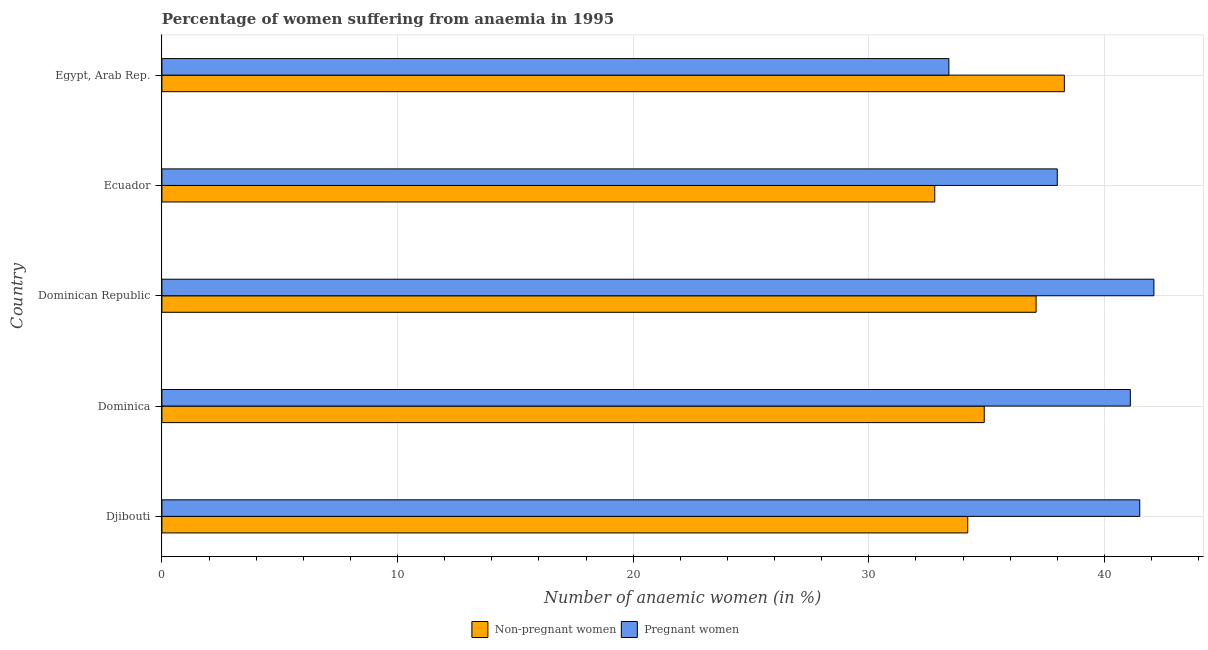How many groups of bars are there?
Provide a short and direct response. 5. Are the number of bars per tick equal to the number of legend labels?
Offer a terse response. Yes. Are the number of bars on each tick of the Y-axis equal?
Offer a terse response. Yes. How many bars are there on the 5th tick from the top?
Your response must be concise. 2. How many bars are there on the 5th tick from the bottom?
Provide a short and direct response. 2. What is the label of the 4th group of bars from the top?
Offer a very short reply. Dominica. In how many cases, is the number of bars for a given country not equal to the number of legend labels?
Your answer should be very brief. 0. What is the percentage of non-pregnant anaemic women in Djibouti?
Provide a succinct answer. 34.2. Across all countries, what is the maximum percentage of pregnant anaemic women?
Your answer should be compact. 42.1. Across all countries, what is the minimum percentage of pregnant anaemic women?
Your response must be concise. 33.4. In which country was the percentage of non-pregnant anaemic women maximum?
Provide a short and direct response. Egypt, Arab Rep. In which country was the percentage of non-pregnant anaemic women minimum?
Offer a very short reply. Ecuador. What is the total percentage of pregnant anaemic women in the graph?
Your answer should be compact. 196.1. What is the difference between the percentage of pregnant anaemic women in Egypt, Arab Rep. and the percentage of non-pregnant anaemic women in Dominica?
Offer a terse response. -1.5. What is the average percentage of pregnant anaemic women per country?
Provide a short and direct response. 39.22. In how many countries, is the percentage of non-pregnant anaemic women greater than 16 %?
Ensure brevity in your answer.  5. What is the ratio of the percentage of non-pregnant anaemic women in Djibouti to that in Dominican Republic?
Keep it short and to the point. 0.92. Is the percentage of pregnant anaemic women in Djibouti less than that in Dominica?
Ensure brevity in your answer.  No. Is the difference between the percentage of pregnant anaemic women in Dominican Republic and Ecuador greater than the difference between the percentage of non-pregnant anaemic women in Dominican Republic and Ecuador?
Give a very brief answer. No. What is the difference between the highest and the lowest percentage of non-pregnant anaemic women?
Your answer should be compact. 5.5. In how many countries, is the percentage of non-pregnant anaemic women greater than the average percentage of non-pregnant anaemic women taken over all countries?
Your response must be concise. 2. Is the sum of the percentage of non-pregnant anaemic women in Dominica and Dominican Republic greater than the maximum percentage of pregnant anaemic women across all countries?
Your answer should be compact. Yes. What does the 1st bar from the top in Egypt, Arab Rep. represents?
Provide a succinct answer. Pregnant women. What does the 1st bar from the bottom in Djibouti represents?
Your answer should be very brief. Non-pregnant women. What is the difference between two consecutive major ticks on the X-axis?
Your answer should be compact. 10. Are the values on the major ticks of X-axis written in scientific E-notation?
Offer a terse response. No. Does the graph contain any zero values?
Make the answer very short. No. Does the graph contain grids?
Your response must be concise. Yes. Where does the legend appear in the graph?
Make the answer very short. Bottom center. How many legend labels are there?
Provide a succinct answer. 2. What is the title of the graph?
Provide a short and direct response. Percentage of women suffering from anaemia in 1995. Does "Pregnant women" appear as one of the legend labels in the graph?
Provide a succinct answer. Yes. What is the label or title of the X-axis?
Provide a short and direct response. Number of anaemic women (in %). What is the label or title of the Y-axis?
Your response must be concise. Country. What is the Number of anaemic women (in %) of Non-pregnant women in Djibouti?
Your answer should be very brief. 34.2. What is the Number of anaemic women (in %) in Pregnant women in Djibouti?
Offer a very short reply. 41.5. What is the Number of anaemic women (in %) in Non-pregnant women in Dominica?
Give a very brief answer. 34.9. What is the Number of anaemic women (in %) in Pregnant women in Dominica?
Ensure brevity in your answer.  41.1. What is the Number of anaemic women (in %) in Non-pregnant women in Dominican Republic?
Provide a short and direct response. 37.1. What is the Number of anaemic women (in %) in Pregnant women in Dominican Republic?
Offer a terse response. 42.1. What is the Number of anaemic women (in %) in Non-pregnant women in Ecuador?
Make the answer very short. 32.8. What is the Number of anaemic women (in %) in Pregnant women in Ecuador?
Your answer should be compact. 38. What is the Number of anaemic women (in %) in Non-pregnant women in Egypt, Arab Rep.?
Give a very brief answer. 38.3. What is the Number of anaemic women (in %) of Pregnant women in Egypt, Arab Rep.?
Give a very brief answer. 33.4. Across all countries, what is the maximum Number of anaemic women (in %) in Non-pregnant women?
Make the answer very short. 38.3. Across all countries, what is the maximum Number of anaemic women (in %) of Pregnant women?
Ensure brevity in your answer.  42.1. Across all countries, what is the minimum Number of anaemic women (in %) in Non-pregnant women?
Your response must be concise. 32.8. Across all countries, what is the minimum Number of anaemic women (in %) in Pregnant women?
Offer a very short reply. 33.4. What is the total Number of anaemic women (in %) of Non-pregnant women in the graph?
Your response must be concise. 177.3. What is the total Number of anaemic women (in %) of Pregnant women in the graph?
Provide a succinct answer. 196.1. What is the difference between the Number of anaemic women (in %) of Pregnant women in Djibouti and that in Dominica?
Ensure brevity in your answer.  0.4. What is the difference between the Number of anaemic women (in %) of Non-pregnant women in Djibouti and that in Dominican Republic?
Your answer should be compact. -2.9. What is the difference between the Number of anaemic women (in %) in Non-pregnant women in Djibouti and that in Ecuador?
Make the answer very short. 1.4. What is the difference between the Number of anaemic women (in %) in Pregnant women in Djibouti and that in Ecuador?
Your answer should be very brief. 3.5. What is the difference between the Number of anaemic women (in %) of Pregnant women in Djibouti and that in Egypt, Arab Rep.?
Offer a very short reply. 8.1. What is the difference between the Number of anaemic women (in %) in Non-pregnant women in Dominica and that in Ecuador?
Provide a succinct answer. 2.1. What is the difference between the Number of anaemic women (in %) of Pregnant women in Dominica and that in Ecuador?
Provide a succinct answer. 3.1. What is the difference between the Number of anaemic women (in %) of Non-pregnant women in Dominican Republic and that in Ecuador?
Your answer should be very brief. 4.3. What is the difference between the Number of anaemic women (in %) in Pregnant women in Dominican Republic and that in Ecuador?
Provide a succinct answer. 4.1. What is the difference between the Number of anaemic women (in %) of Pregnant women in Ecuador and that in Egypt, Arab Rep.?
Your answer should be compact. 4.6. What is the difference between the Number of anaemic women (in %) of Non-pregnant women in Djibouti and the Number of anaemic women (in %) of Pregnant women in Ecuador?
Your answer should be very brief. -3.8. What is the difference between the Number of anaemic women (in %) of Non-pregnant women in Djibouti and the Number of anaemic women (in %) of Pregnant women in Egypt, Arab Rep.?
Your response must be concise. 0.8. What is the difference between the Number of anaemic women (in %) in Non-pregnant women in Dominica and the Number of anaemic women (in %) in Pregnant women in Dominican Republic?
Offer a terse response. -7.2. What is the difference between the Number of anaemic women (in %) in Non-pregnant women in Dominican Republic and the Number of anaemic women (in %) in Pregnant women in Egypt, Arab Rep.?
Offer a terse response. 3.7. What is the average Number of anaemic women (in %) in Non-pregnant women per country?
Offer a very short reply. 35.46. What is the average Number of anaemic women (in %) in Pregnant women per country?
Your response must be concise. 39.22. What is the difference between the Number of anaemic women (in %) in Non-pregnant women and Number of anaemic women (in %) in Pregnant women in Djibouti?
Make the answer very short. -7.3. What is the ratio of the Number of anaemic women (in %) in Non-pregnant women in Djibouti to that in Dominica?
Provide a succinct answer. 0.98. What is the ratio of the Number of anaemic women (in %) in Pregnant women in Djibouti to that in Dominica?
Keep it short and to the point. 1.01. What is the ratio of the Number of anaemic women (in %) of Non-pregnant women in Djibouti to that in Dominican Republic?
Keep it short and to the point. 0.92. What is the ratio of the Number of anaemic women (in %) of Pregnant women in Djibouti to that in Dominican Republic?
Keep it short and to the point. 0.99. What is the ratio of the Number of anaemic women (in %) in Non-pregnant women in Djibouti to that in Ecuador?
Offer a very short reply. 1.04. What is the ratio of the Number of anaemic women (in %) in Pregnant women in Djibouti to that in Ecuador?
Make the answer very short. 1.09. What is the ratio of the Number of anaemic women (in %) in Non-pregnant women in Djibouti to that in Egypt, Arab Rep.?
Make the answer very short. 0.89. What is the ratio of the Number of anaemic women (in %) of Pregnant women in Djibouti to that in Egypt, Arab Rep.?
Your answer should be very brief. 1.24. What is the ratio of the Number of anaemic women (in %) of Non-pregnant women in Dominica to that in Dominican Republic?
Offer a very short reply. 0.94. What is the ratio of the Number of anaemic women (in %) in Pregnant women in Dominica to that in Dominican Republic?
Your answer should be compact. 0.98. What is the ratio of the Number of anaemic women (in %) of Non-pregnant women in Dominica to that in Ecuador?
Offer a very short reply. 1.06. What is the ratio of the Number of anaemic women (in %) in Pregnant women in Dominica to that in Ecuador?
Offer a very short reply. 1.08. What is the ratio of the Number of anaemic women (in %) of Non-pregnant women in Dominica to that in Egypt, Arab Rep.?
Give a very brief answer. 0.91. What is the ratio of the Number of anaemic women (in %) of Pregnant women in Dominica to that in Egypt, Arab Rep.?
Give a very brief answer. 1.23. What is the ratio of the Number of anaemic women (in %) of Non-pregnant women in Dominican Republic to that in Ecuador?
Offer a very short reply. 1.13. What is the ratio of the Number of anaemic women (in %) of Pregnant women in Dominican Republic to that in Ecuador?
Provide a short and direct response. 1.11. What is the ratio of the Number of anaemic women (in %) of Non-pregnant women in Dominican Republic to that in Egypt, Arab Rep.?
Give a very brief answer. 0.97. What is the ratio of the Number of anaemic women (in %) of Pregnant women in Dominican Republic to that in Egypt, Arab Rep.?
Make the answer very short. 1.26. What is the ratio of the Number of anaemic women (in %) in Non-pregnant women in Ecuador to that in Egypt, Arab Rep.?
Make the answer very short. 0.86. What is the ratio of the Number of anaemic women (in %) of Pregnant women in Ecuador to that in Egypt, Arab Rep.?
Provide a succinct answer. 1.14. What is the difference between the highest and the second highest Number of anaemic women (in %) in Non-pregnant women?
Your answer should be very brief. 1.2. What is the difference between the highest and the second highest Number of anaemic women (in %) in Pregnant women?
Provide a short and direct response. 0.6. What is the difference between the highest and the lowest Number of anaemic women (in %) of Pregnant women?
Make the answer very short. 8.7. 